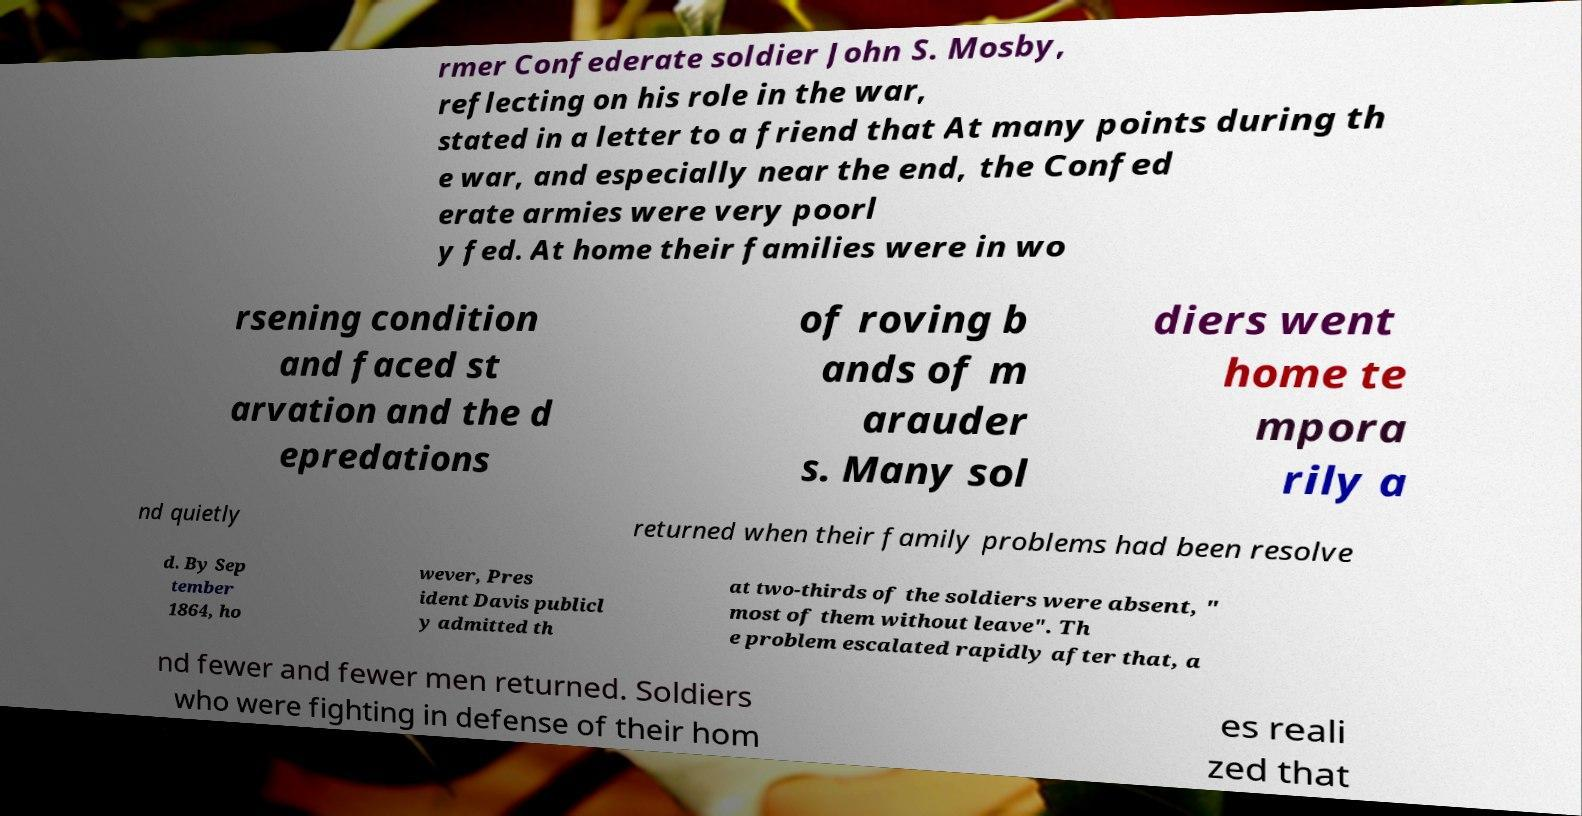Could you assist in decoding the text presented in this image and type it out clearly? rmer Confederate soldier John S. Mosby, reflecting on his role in the war, stated in a letter to a friend that At many points during th e war, and especially near the end, the Confed erate armies were very poorl y fed. At home their families were in wo rsening condition and faced st arvation and the d epredations of roving b ands of m arauder s. Many sol diers went home te mpora rily a nd quietly returned when their family problems had been resolve d. By Sep tember 1864, ho wever, Pres ident Davis publicl y admitted th at two-thirds of the soldiers were absent, " most of them without leave". Th e problem escalated rapidly after that, a nd fewer and fewer men returned. Soldiers who were fighting in defense of their hom es reali zed that 